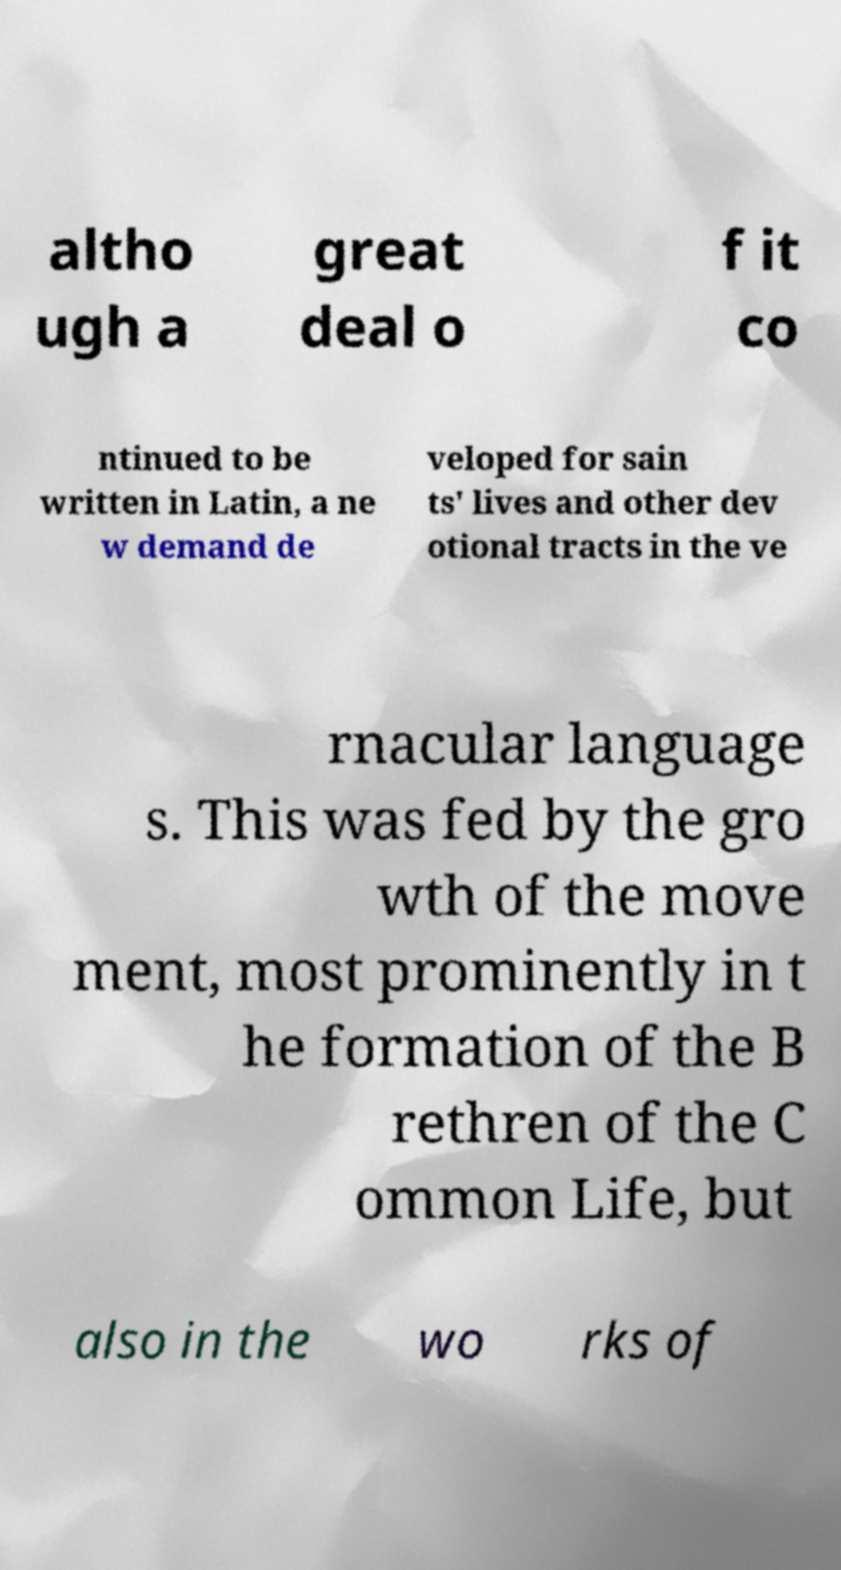Please read and relay the text visible in this image. What does it say? altho ugh a great deal o f it co ntinued to be written in Latin, a ne w demand de veloped for sain ts' lives and other dev otional tracts in the ve rnacular language s. This was fed by the gro wth of the move ment, most prominently in t he formation of the B rethren of the C ommon Life, but also in the wo rks of 